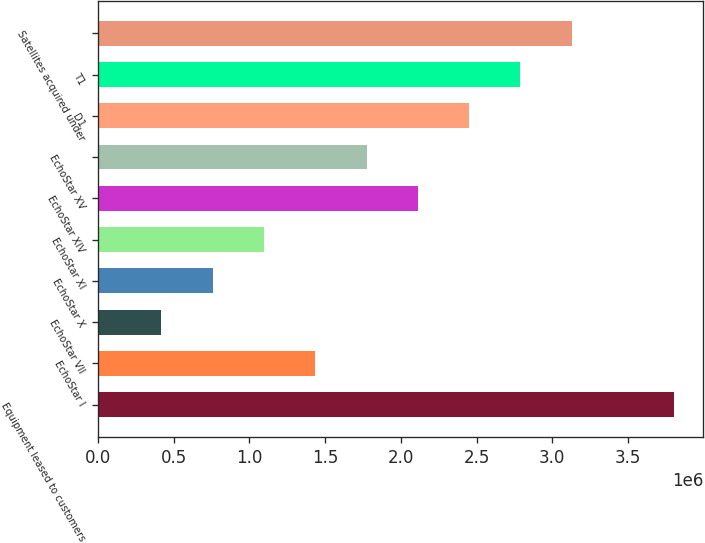Convert chart. <chart><loc_0><loc_0><loc_500><loc_500><bar_chart><fcel>Equipment leased to customers<fcel>EchoStar I<fcel>EchoStar VII<fcel>EchoStar X<fcel>EchoStar XI<fcel>EchoStar XIV<fcel>EchoStar XV<fcel>D1<fcel>T1<fcel>Satellites acquired under<nl><fcel>3.80575e+06<fcel>1.43474e+06<fcel>418585<fcel>757302<fcel>1.09602e+06<fcel>2.11217e+06<fcel>1.77345e+06<fcel>2.45089e+06<fcel>2.7896e+06<fcel>3.12832e+06<nl></chart> 